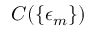<formula> <loc_0><loc_0><loc_500><loc_500>C ( \{ \epsilon _ { m } \} )</formula> 